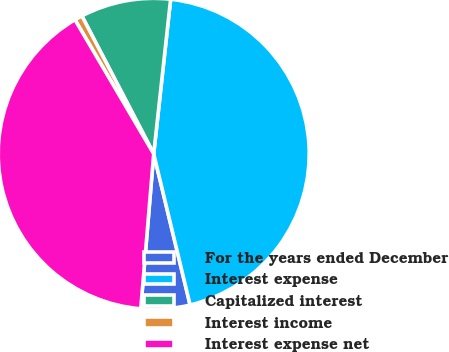Convert chart. <chart><loc_0><loc_0><loc_500><loc_500><pie_chart><fcel>For the years ended December<fcel>Interest expense<fcel>Capitalized interest<fcel>Interest income<fcel>Interest expense net<nl><fcel>5.09%<fcel>44.51%<fcel>9.38%<fcel>0.81%<fcel>40.22%<nl></chart> 